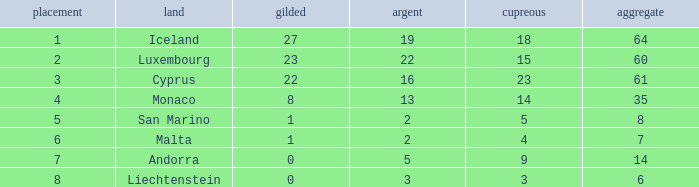How many golds for the nation with 14 total? 0.0. Help me parse the entirety of this table. {'header': ['placement', 'land', 'gilded', 'argent', 'cupreous', 'aggregate'], 'rows': [['1', 'Iceland', '27', '19', '18', '64'], ['2', 'Luxembourg', '23', '22', '15', '60'], ['3', 'Cyprus', '22', '16', '23', '61'], ['4', 'Monaco', '8', '13', '14', '35'], ['5', 'San Marino', '1', '2', '5', '8'], ['6', 'Malta', '1', '2', '4', '7'], ['7', 'Andorra', '0', '5', '9', '14'], ['8', 'Liechtenstein', '0', '3', '3', '6']]} 